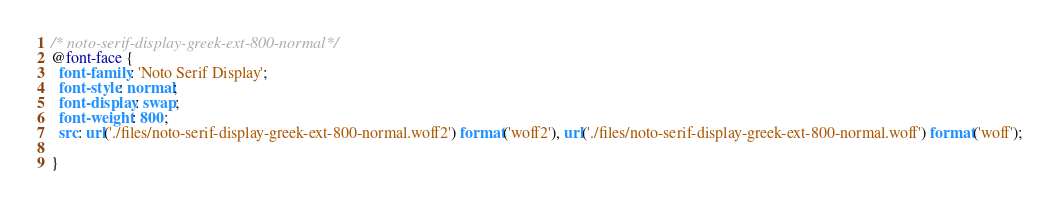Convert code to text. <code><loc_0><loc_0><loc_500><loc_500><_CSS_>/* noto-serif-display-greek-ext-800-normal*/
@font-face {
  font-family: 'Noto Serif Display';
  font-style: normal;
  font-display: swap;
  font-weight: 800;
  src: url('./files/noto-serif-display-greek-ext-800-normal.woff2') format('woff2'), url('./files/noto-serif-display-greek-ext-800-normal.woff') format('woff');
  
}
</code> 